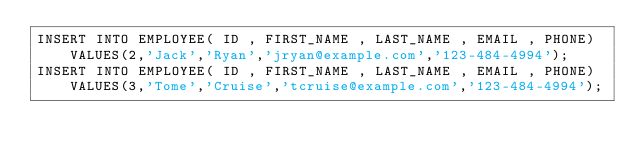Convert code to text. <code><loc_0><loc_0><loc_500><loc_500><_SQL_>INSERT INTO EMPLOYEE( ID , FIRST_NAME , LAST_NAME , EMAIL , PHONE) VALUES(2,'Jack','Ryan','jryan@example.com','123-484-4994');
INSERT INTO EMPLOYEE( ID , FIRST_NAME , LAST_NAME , EMAIL , PHONE) VALUES(3,'Tome','Cruise','tcruise@example.com','123-484-4994');</code> 